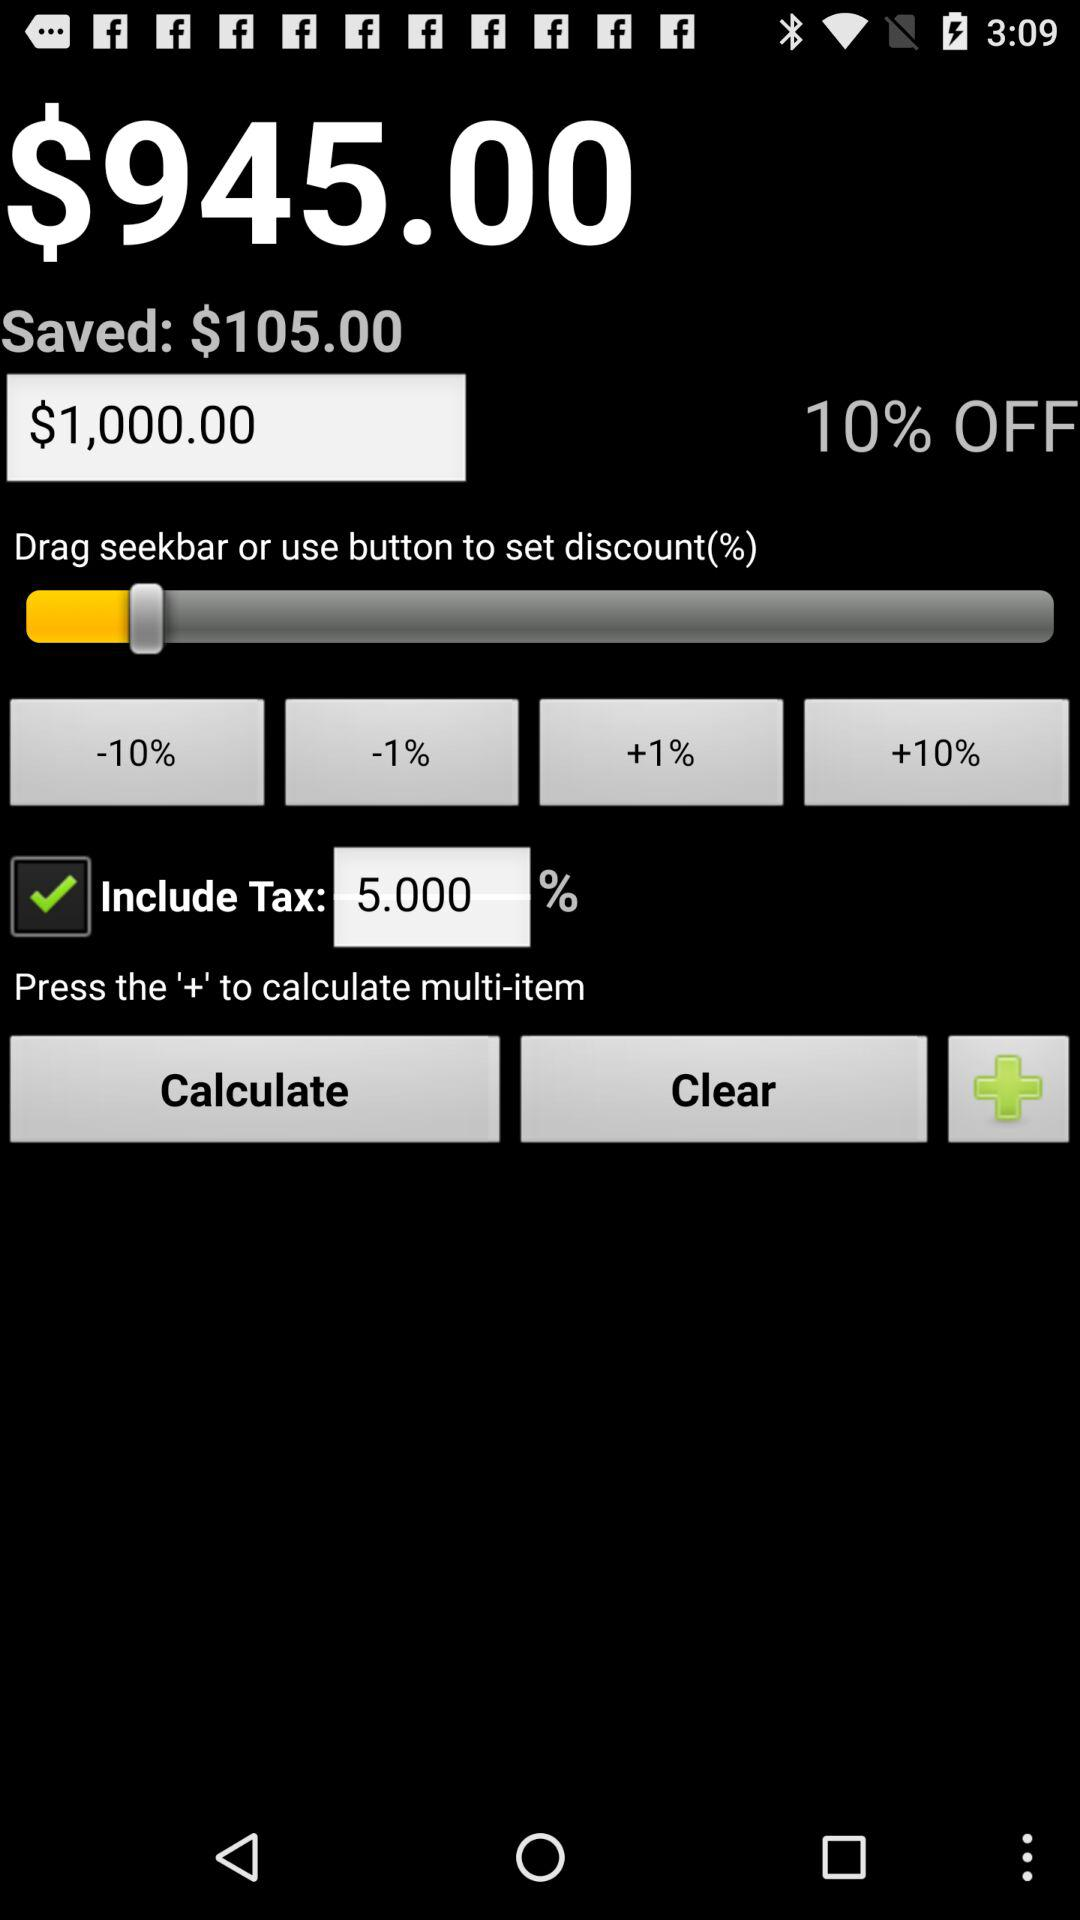What is the discount percentage?
Answer the question using a single word or phrase. 10% 